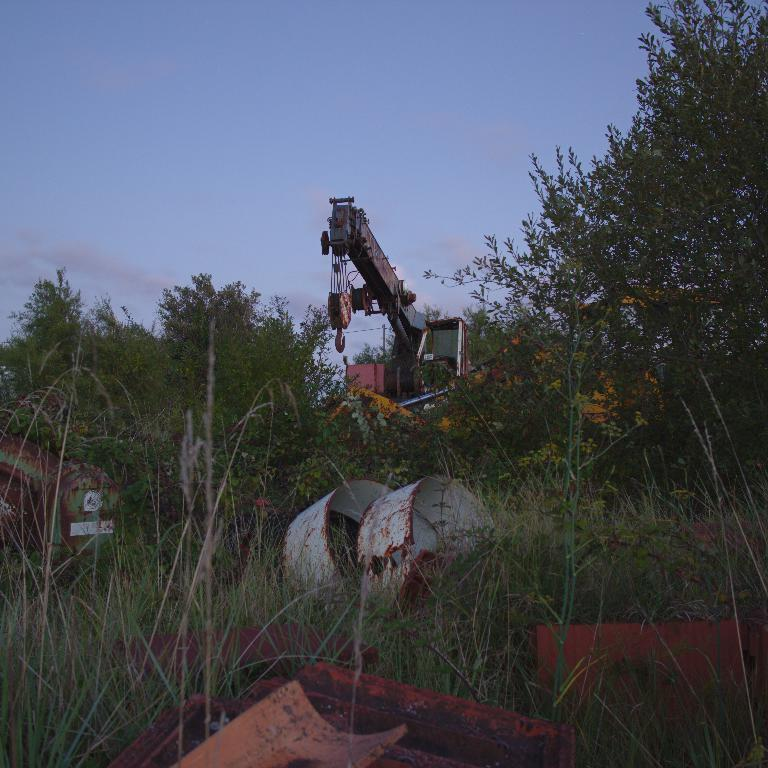What is the main subject of the image? There is a crane in the image. Where is the crane located in relation to other objects? The crane is between trees. What can be seen at the bottom of the image? There is scrap at the bottom of the image. What is visible in the background of the image? There is a sky visible in the background of the image. What color crayon can be seen in the image? There is no crayon present in the image. Is there a car parked near the crane in the image? There is no car visible in the image; only the crane, trees, scrap, and sky are present. 